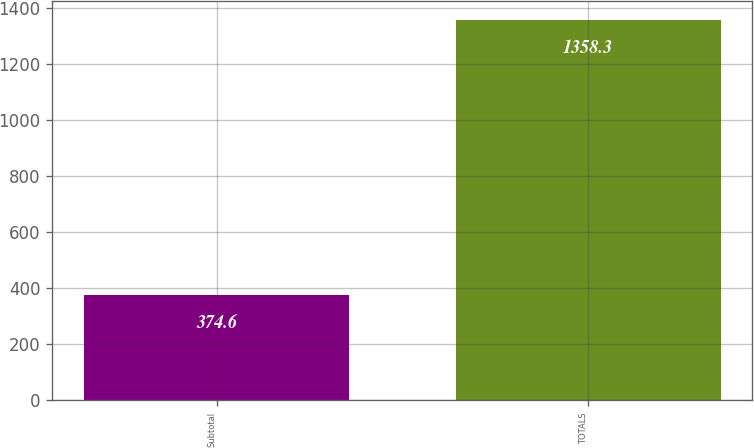<chart> <loc_0><loc_0><loc_500><loc_500><bar_chart><fcel>Subtotal<fcel>TOTALS<nl><fcel>374.6<fcel>1358.3<nl></chart> 